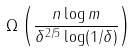<formula> <loc_0><loc_0><loc_500><loc_500>\Omega \left ( \frac { n \log m } { \delta ^ { 2 / 5 } \log ( 1 / \delta ) } \right )</formula> 